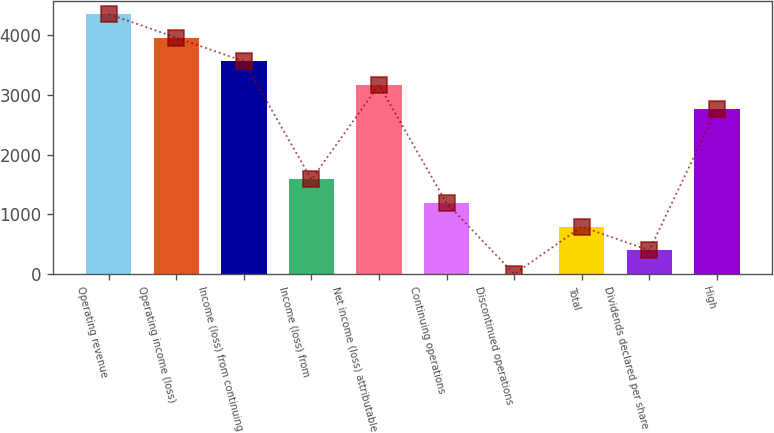Convert chart. <chart><loc_0><loc_0><loc_500><loc_500><bar_chart><fcel>Operating revenue<fcel>Operating income (loss)<fcel>Income (loss) from continuing<fcel>Income (loss) from<fcel>Net income (loss) attributable<fcel>Continuing operations<fcel>Discontinued operations<fcel>Total<fcel>Dividends declared per share<fcel>High<nl><fcel>4355.97<fcel>3959.98<fcel>3563.99<fcel>1584.04<fcel>3168<fcel>1188.05<fcel>0.08<fcel>792.06<fcel>396.07<fcel>2772.01<nl></chart> 